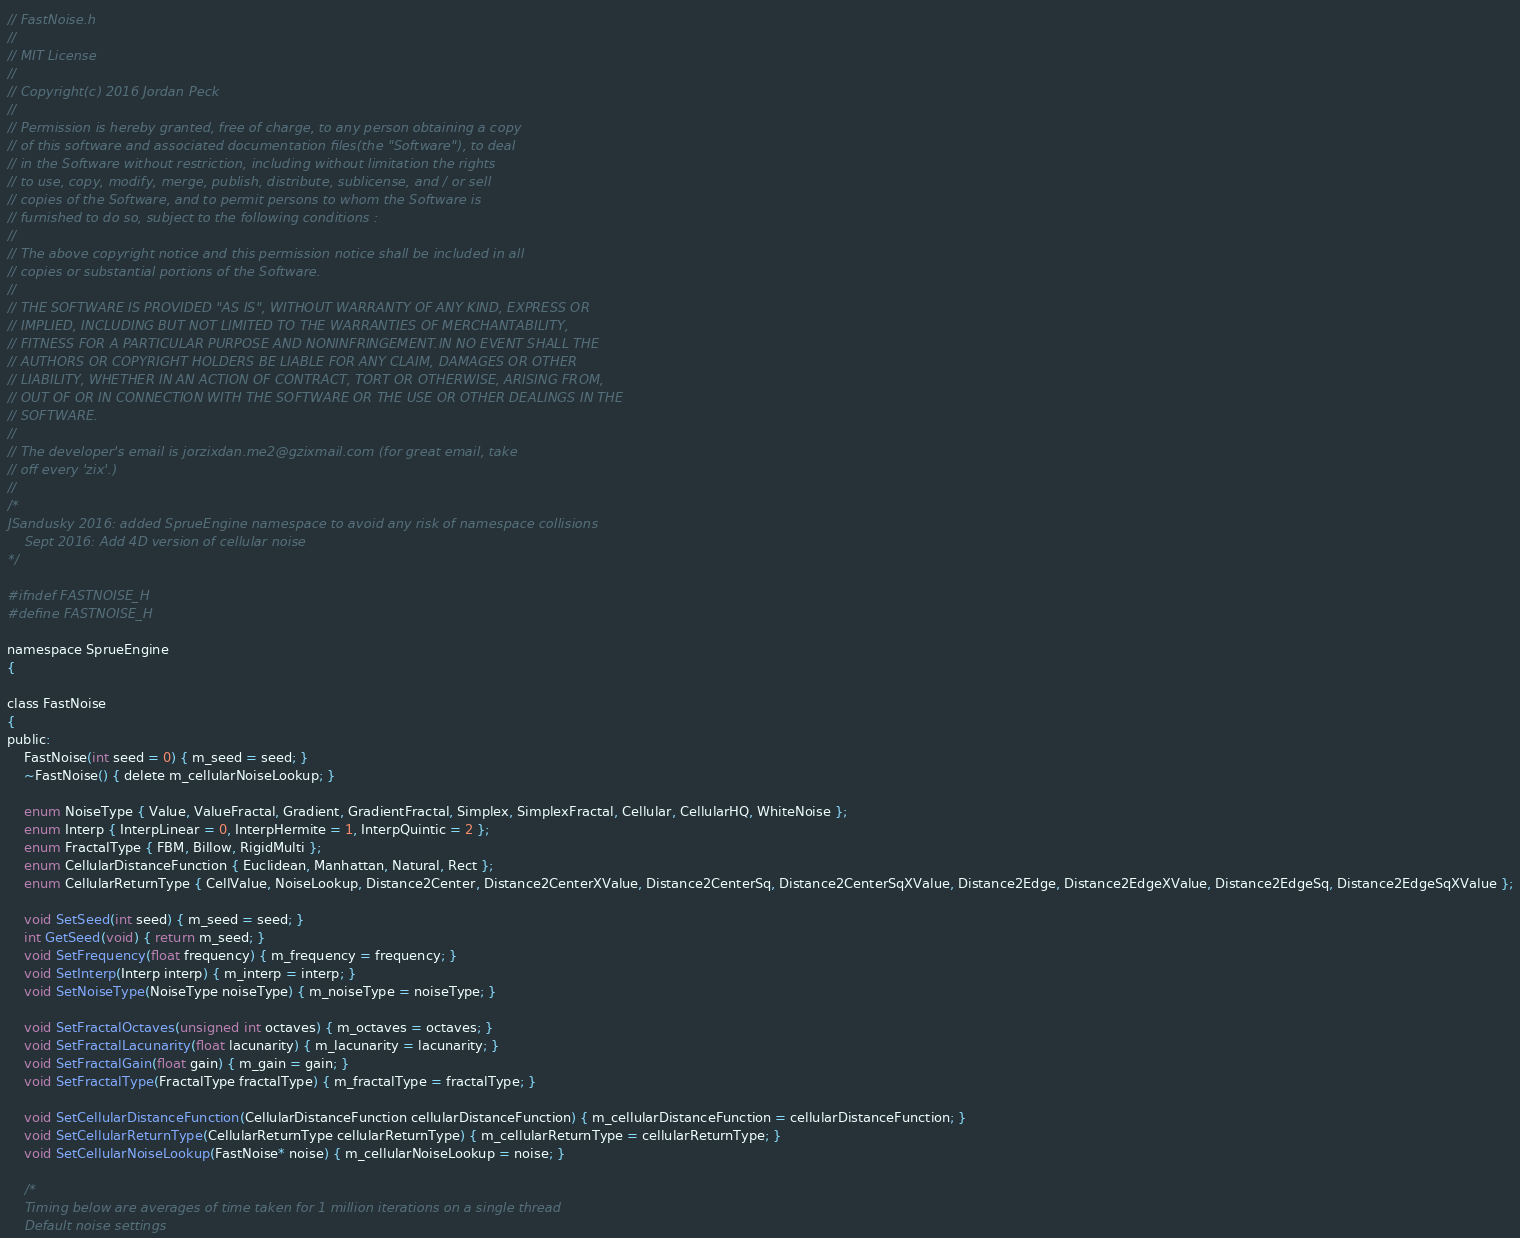<code> <loc_0><loc_0><loc_500><loc_500><_C_>// FastNoise.h
//
// MIT License
//
// Copyright(c) 2016 Jordan Peck
//
// Permission is hereby granted, free of charge, to any person obtaining a copy
// of this software and associated documentation files(the "Software"), to deal
// in the Software without restriction, including without limitation the rights
// to use, copy, modify, merge, publish, distribute, sublicense, and / or sell
// copies of the Software, and to permit persons to whom the Software is
// furnished to do so, subject to the following conditions :
//
// The above copyright notice and this permission notice shall be included in all
// copies or substantial portions of the Software.
//
// THE SOFTWARE IS PROVIDED "AS IS", WITHOUT WARRANTY OF ANY KIND, EXPRESS OR
// IMPLIED, INCLUDING BUT NOT LIMITED TO THE WARRANTIES OF MERCHANTABILITY,
// FITNESS FOR A PARTICULAR PURPOSE AND NONINFRINGEMENT.IN NO EVENT SHALL THE
// AUTHORS OR COPYRIGHT HOLDERS BE LIABLE FOR ANY CLAIM, DAMAGES OR OTHER
// LIABILITY, WHETHER IN AN ACTION OF CONTRACT, TORT OR OTHERWISE, ARISING FROM,
// OUT OF OR IN CONNECTION WITH THE SOFTWARE OR THE USE OR OTHER DEALINGS IN THE
// SOFTWARE.
//
// The developer's email is jorzixdan.me2@gzixmail.com (for great email, take
// off every 'zix'.)
//
/* 
JSandusky 2016: added SprueEngine namespace to avoid any risk of namespace collisions 
    Sept 2016: Add 4D version of cellular noise
*/

#ifndef FASTNOISE_H
#define FASTNOISE_H

namespace SprueEngine
{

class FastNoise
{
public:
	FastNoise(int seed = 0) { m_seed = seed; }
	~FastNoise() { delete m_cellularNoiseLookup; }

	enum NoiseType { Value, ValueFractal, Gradient, GradientFractal, Simplex, SimplexFractal, Cellular, CellularHQ, WhiteNoise };
	enum Interp { InterpLinear = 0, InterpHermite = 1, InterpQuintic = 2 };
	enum FractalType { FBM, Billow, RigidMulti };
    enum CellularDistanceFunction { Euclidean, Manhattan, Natural, Rect };
	enum CellularReturnType { CellValue, NoiseLookup, Distance2Center, Distance2CenterXValue, Distance2CenterSq, Distance2CenterSqXValue, Distance2Edge, Distance2EdgeXValue, Distance2EdgeSq, Distance2EdgeSqXValue };

	void SetSeed(int seed) { m_seed = seed; }
	int GetSeed(void) { return m_seed; }
	void SetFrequency(float frequency) { m_frequency = frequency; }
	void SetInterp(Interp interp) { m_interp = interp; }
	void SetNoiseType(NoiseType noiseType) { m_noiseType = noiseType; }

	void SetFractalOctaves(unsigned int octaves) { m_octaves = octaves; }
	void SetFractalLacunarity(float lacunarity) { m_lacunarity = lacunarity; }
	void SetFractalGain(float gain) { m_gain = gain; }
	void SetFractalType(FractalType fractalType) { m_fractalType = fractalType; }

	void SetCellularDistanceFunction(CellularDistanceFunction cellularDistanceFunction) { m_cellularDistanceFunction = cellularDistanceFunction; }
	void SetCellularReturnType(CellularReturnType cellularReturnType) { m_cellularReturnType = cellularReturnType; }
	void SetCellularNoiseLookup(FastNoise* noise) { m_cellularNoiseLookup = noise; }

	/*
	Timing below are averages of time taken for 1 million iterations on a single thread
	Default noise settings</code> 